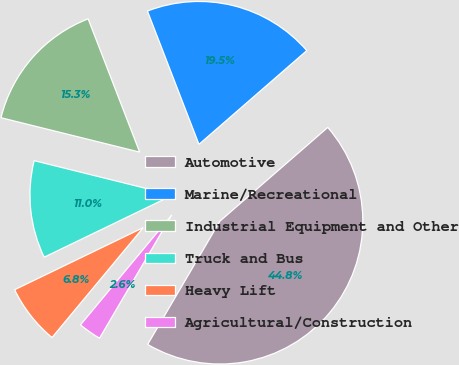Convert chart to OTSL. <chart><loc_0><loc_0><loc_500><loc_500><pie_chart><fcel>Automotive<fcel>Marine/Recreational<fcel>Industrial Equipment and Other<fcel>Truck and Bus<fcel>Heavy Lift<fcel>Agricultural/Construction<nl><fcel>44.83%<fcel>19.48%<fcel>15.26%<fcel>11.03%<fcel>6.81%<fcel>2.59%<nl></chart> 